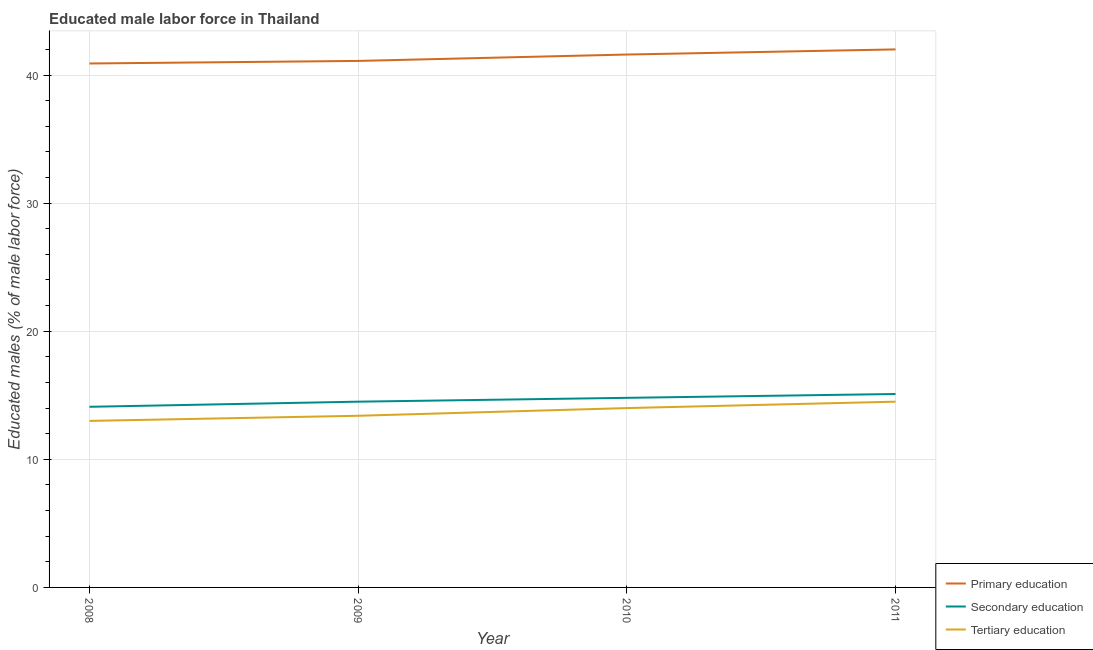Does the line corresponding to percentage of male labor force who received tertiary education intersect with the line corresponding to percentage of male labor force who received primary education?
Offer a terse response. No. Is the number of lines equal to the number of legend labels?
Provide a succinct answer. Yes. What is the percentage of male labor force who received secondary education in 2011?
Provide a short and direct response. 15.1. Across all years, what is the maximum percentage of male labor force who received secondary education?
Keep it short and to the point. 15.1. Across all years, what is the minimum percentage of male labor force who received primary education?
Make the answer very short. 40.9. What is the total percentage of male labor force who received primary education in the graph?
Provide a succinct answer. 165.6. What is the difference between the percentage of male labor force who received primary education in 2008 and that in 2011?
Make the answer very short. -1.1. What is the average percentage of male labor force who received primary education per year?
Your answer should be very brief. 41.4. In the year 2009, what is the difference between the percentage of male labor force who received secondary education and percentage of male labor force who received primary education?
Your response must be concise. -26.6. In how many years, is the percentage of male labor force who received tertiary education greater than 30 %?
Provide a short and direct response. 0. What is the ratio of the percentage of male labor force who received secondary education in 2008 to that in 2010?
Your answer should be compact. 0.95. Is the difference between the percentage of male labor force who received tertiary education in 2008 and 2010 greater than the difference between the percentage of male labor force who received primary education in 2008 and 2010?
Give a very brief answer. No. What is the difference between the highest and the second highest percentage of male labor force who received primary education?
Ensure brevity in your answer.  0.4. What is the difference between the highest and the lowest percentage of male labor force who received tertiary education?
Give a very brief answer. 1.5. In how many years, is the percentage of male labor force who received primary education greater than the average percentage of male labor force who received primary education taken over all years?
Provide a succinct answer. 2. Is the sum of the percentage of male labor force who received tertiary education in 2010 and 2011 greater than the maximum percentage of male labor force who received primary education across all years?
Your response must be concise. No. Is the percentage of male labor force who received tertiary education strictly greater than the percentage of male labor force who received secondary education over the years?
Your answer should be very brief. No. How many lines are there?
Your answer should be compact. 3. How many years are there in the graph?
Your answer should be very brief. 4. What is the difference between two consecutive major ticks on the Y-axis?
Keep it short and to the point. 10. Does the graph contain any zero values?
Make the answer very short. No. Does the graph contain grids?
Your answer should be very brief. Yes. How many legend labels are there?
Your answer should be very brief. 3. How are the legend labels stacked?
Offer a very short reply. Vertical. What is the title of the graph?
Keep it short and to the point. Educated male labor force in Thailand. What is the label or title of the X-axis?
Your answer should be compact. Year. What is the label or title of the Y-axis?
Make the answer very short. Educated males (% of male labor force). What is the Educated males (% of male labor force) in Primary education in 2008?
Give a very brief answer. 40.9. What is the Educated males (% of male labor force) in Secondary education in 2008?
Make the answer very short. 14.1. What is the Educated males (% of male labor force) of Primary education in 2009?
Your answer should be very brief. 41.1. What is the Educated males (% of male labor force) of Secondary education in 2009?
Your answer should be compact. 14.5. What is the Educated males (% of male labor force) in Tertiary education in 2009?
Keep it short and to the point. 13.4. What is the Educated males (% of male labor force) of Primary education in 2010?
Offer a terse response. 41.6. What is the Educated males (% of male labor force) of Secondary education in 2010?
Ensure brevity in your answer.  14.8. What is the Educated males (% of male labor force) of Tertiary education in 2010?
Your answer should be compact. 14. What is the Educated males (% of male labor force) in Secondary education in 2011?
Make the answer very short. 15.1. What is the Educated males (% of male labor force) of Tertiary education in 2011?
Provide a short and direct response. 14.5. Across all years, what is the maximum Educated males (% of male labor force) in Secondary education?
Your answer should be very brief. 15.1. Across all years, what is the maximum Educated males (% of male labor force) of Tertiary education?
Offer a very short reply. 14.5. Across all years, what is the minimum Educated males (% of male labor force) of Primary education?
Your response must be concise. 40.9. Across all years, what is the minimum Educated males (% of male labor force) in Secondary education?
Offer a very short reply. 14.1. Across all years, what is the minimum Educated males (% of male labor force) of Tertiary education?
Give a very brief answer. 13. What is the total Educated males (% of male labor force) in Primary education in the graph?
Your response must be concise. 165.6. What is the total Educated males (% of male labor force) in Secondary education in the graph?
Your answer should be very brief. 58.5. What is the total Educated males (% of male labor force) in Tertiary education in the graph?
Keep it short and to the point. 54.9. What is the difference between the Educated males (% of male labor force) in Primary education in 2008 and that in 2009?
Provide a succinct answer. -0.2. What is the difference between the Educated males (% of male labor force) in Tertiary education in 2008 and that in 2009?
Ensure brevity in your answer.  -0.4. What is the difference between the Educated males (% of male labor force) in Tertiary education in 2008 and that in 2010?
Offer a very short reply. -1. What is the difference between the Educated males (% of male labor force) in Primary education in 2008 and that in 2011?
Ensure brevity in your answer.  -1.1. What is the difference between the Educated males (% of male labor force) of Tertiary education in 2008 and that in 2011?
Make the answer very short. -1.5. What is the difference between the Educated males (% of male labor force) in Primary education in 2009 and that in 2010?
Provide a short and direct response. -0.5. What is the difference between the Educated males (% of male labor force) of Tertiary education in 2009 and that in 2010?
Give a very brief answer. -0.6. What is the difference between the Educated males (% of male labor force) of Secondary education in 2009 and that in 2011?
Give a very brief answer. -0.6. What is the difference between the Educated males (% of male labor force) of Primary education in 2010 and that in 2011?
Your answer should be very brief. -0.4. What is the difference between the Educated males (% of male labor force) in Secondary education in 2010 and that in 2011?
Your answer should be very brief. -0.3. What is the difference between the Educated males (% of male labor force) of Primary education in 2008 and the Educated males (% of male labor force) of Secondary education in 2009?
Your answer should be compact. 26.4. What is the difference between the Educated males (% of male labor force) of Secondary education in 2008 and the Educated males (% of male labor force) of Tertiary education in 2009?
Ensure brevity in your answer.  0.7. What is the difference between the Educated males (% of male labor force) in Primary education in 2008 and the Educated males (% of male labor force) in Secondary education in 2010?
Your answer should be compact. 26.1. What is the difference between the Educated males (% of male labor force) of Primary education in 2008 and the Educated males (% of male labor force) of Tertiary education in 2010?
Offer a terse response. 26.9. What is the difference between the Educated males (% of male labor force) of Secondary education in 2008 and the Educated males (% of male labor force) of Tertiary education in 2010?
Offer a very short reply. 0.1. What is the difference between the Educated males (% of male labor force) in Primary education in 2008 and the Educated males (% of male labor force) in Secondary education in 2011?
Ensure brevity in your answer.  25.8. What is the difference between the Educated males (% of male labor force) in Primary education in 2008 and the Educated males (% of male labor force) in Tertiary education in 2011?
Give a very brief answer. 26.4. What is the difference between the Educated males (% of male labor force) in Primary education in 2009 and the Educated males (% of male labor force) in Secondary education in 2010?
Your answer should be compact. 26.3. What is the difference between the Educated males (% of male labor force) of Primary education in 2009 and the Educated males (% of male labor force) of Tertiary education in 2010?
Ensure brevity in your answer.  27.1. What is the difference between the Educated males (% of male labor force) of Secondary education in 2009 and the Educated males (% of male labor force) of Tertiary education in 2010?
Offer a very short reply. 0.5. What is the difference between the Educated males (% of male labor force) in Primary education in 2009 and the Educated males (% of male labor force) in Secondary education in 2011?
Provide a succinct answer. 26. What is the difference between the Educated males (% of male labor force) in Primary education in 2009 and the Educated males (% of male labor force) in Tertiary education in 2011?
Make the answer very short. 26.6. What is the difference between the Educated males (% of male labor force) of Secondary education in 2009 and the Educated males (% of male labor force) of Tertiary education in 2011?
Your answer should be compact. 0. What is the difference between the Educated males (% of male labor force) of Primary education in 2010 and the Educated males (% of male labor force) of Secondary education in 2011?
Make the answer very short. 26.5. What is the difference between the Educated males (% of male labor force) of Primary education in 2010 and the Educated males (% of male labor force) of Tertiary education in 2011?
Make the answer very short. 27.1. What is the difference between the Educated males (% of male labor force) in Secondary education in 2010 and the Educated males (% of male labor force) in Tertiary education in 2011?
Your answer should be very brief. 0.3. What is the average Educated males (% of male labor force) in Primary education per year?
Provide a succinct answer. 41.4. What is the average Educated males (% of male labor force) in Secondary education per year?
Your answer should be compact. 14.62. What is the average Educated males (% of male labor force) of Tertiary education per year?
Provide a succinct answer. 13.72. In the year 2008, what is the difference between the Educated males (% of male labor force) in Primary education and Educated males (% of male labor force) in Secondary education?
Offer a terse response. 26.8. In the year 2008, what is the difference between the Educated males (% of male labor force) of Primary education and Educated males (% of male labor force) of Tertiary education?
Offer a terse response. 27.9. In the year 2008, what is the difference between the Educated males (% of male labor force) of Secondary education and Educated males (% of male labor force) of Tertiary education?
Offer a very short reply. 1.1. In the year 2009, what is the difference between the Educated males (% of male labor force) in Primary education and Educated males (% of male labor force) in Secondary education?
Keep it short and to the point. 26.6. In the year 2009, what is the difference between the Educated males (% of male labor force) in Primary education and Educated males (% of male labor force) in Tertiary education?
Provide a short and direct response. 27.7. In the year 2010, what is the difference between the Educated males (% of male labor force) in Primary education and Educated males (% of male labor force) in Secondary education?
Give a very brief answer. 26.8. In the year 2010, what is the difference between the Educated males (% of male labor force) of Primary education and Educated males (% of male labor force) of Tertiary education?
Provide a succinct answer. 27.6. In the year 2011, what is the difference between the Educated males (% of male labor force) of Primary education and Educated males (% of male labor force) of Secondary education?
Your answer should be very brief. 26.9. What is the ratio of the Educated males (% of male labor force) of Primary education in 2008 to that in 2009?
Your response must be concise. 1. What is the ratio of the Educated males (% of male labor force) in Secondary education in 2008 to that in 2009?
Ensure brevity in your answer.  0.97. What is the ratio of the Educated males (% of male labor force) of Tertiary education in 2008 to that in 2009?
Provide a short and direct response. 0.97. What is the ratio of the Educated males (% of male labor force) in Primary education in 2008 to that in 2010?
Offer a terse response. 0.98. What is the ratio of the Educated males (% of male labor force) of Secondary education in 2008 to that in 2010?
Your response must be concise. 0.95. What is the ratio of the Educated males (% of male labor force) in Primary education in 2008 to that in 2011?
Provide a succinct answer. 0.97. What is the ratio of the Educated males (% of male labor force) of Secondary education in 2008 to that in 2011?
Your answer should be compact. 0.93. What is the ratio of the Educated males (% of male labor force) of Tertiary education in 2008 to that in 2011?
Your response must be concise. 0.9. What is the ratio of the Educated males (% of male labor force) in Secondary education in 2009 to that in 2010?
Offer a very short reply. 0.98. What is the ratio of the Educated males (% of male labor force) of Tertiary education in 2009 to that in 2010?
Make the answer very short. 0.96. What is the ratio of the Educated males (% of male labor force) in Primary education in 2009 to that in 2011?
Offer a very short reply. 0.98. What is the ratio of the Educated males (% of male labor force) in Secondary education in 2009 to that in 2011?
Keep it short and to the point. 0.96. What is the ratio of the Educated males (% of male labor force) in Tertiary education in 2009 to that in 2011?
Provide a succinct answer. 0.92. What is the ratio of the Educated males (% of male labor force) of Primary education in 2010 to that in 2011?
Your answer should be very brief. 0.99. What is the ratio of the Educated males (% of male labor force) of Secondary education in 2010 to that in 2011?
Your answer should be very brief. 0.98. What is the ratio of the Educated males (% of male labor force) of Tertiary education in 2010 to that in 2011?
Keep it short and to the point. 0.97. What is the difference between the highest and the second highest Educated males (% of male labor force) in Primary education?
Offer a terse response. 0.4. What is the difference between the highest and the second highest Educated males (% of male labor force) in Secondary education?
Give a very brief answer. 0.3. What is the difference between the highest and the lowest Educated males (% of male labor force) in Primary education?
Give a very brief answer. 1.1. What is the difference between the highest and the lowest Educated males (% of male labor force) of Tertiary education?
Give a very brief answer. 1.5. 